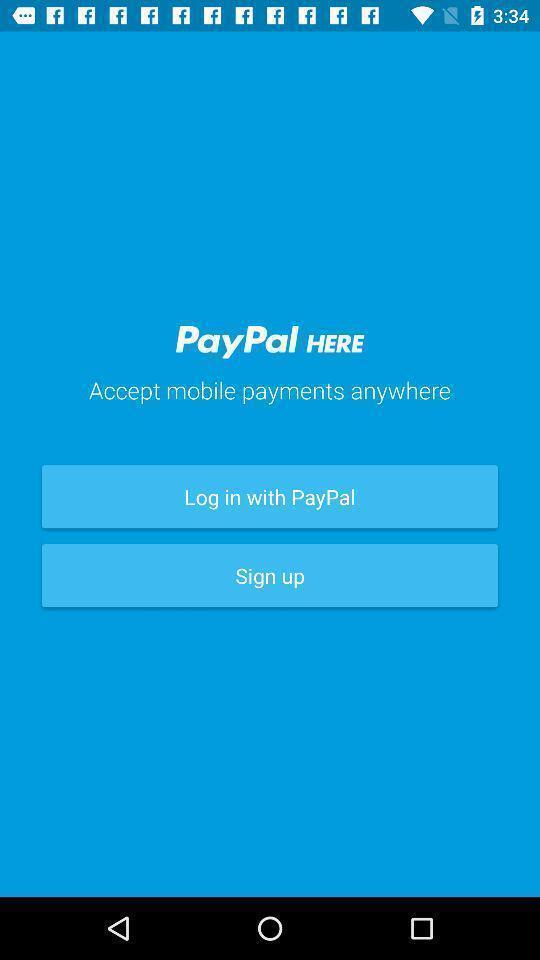Describe this image in words. Welcome page of a payment app. 